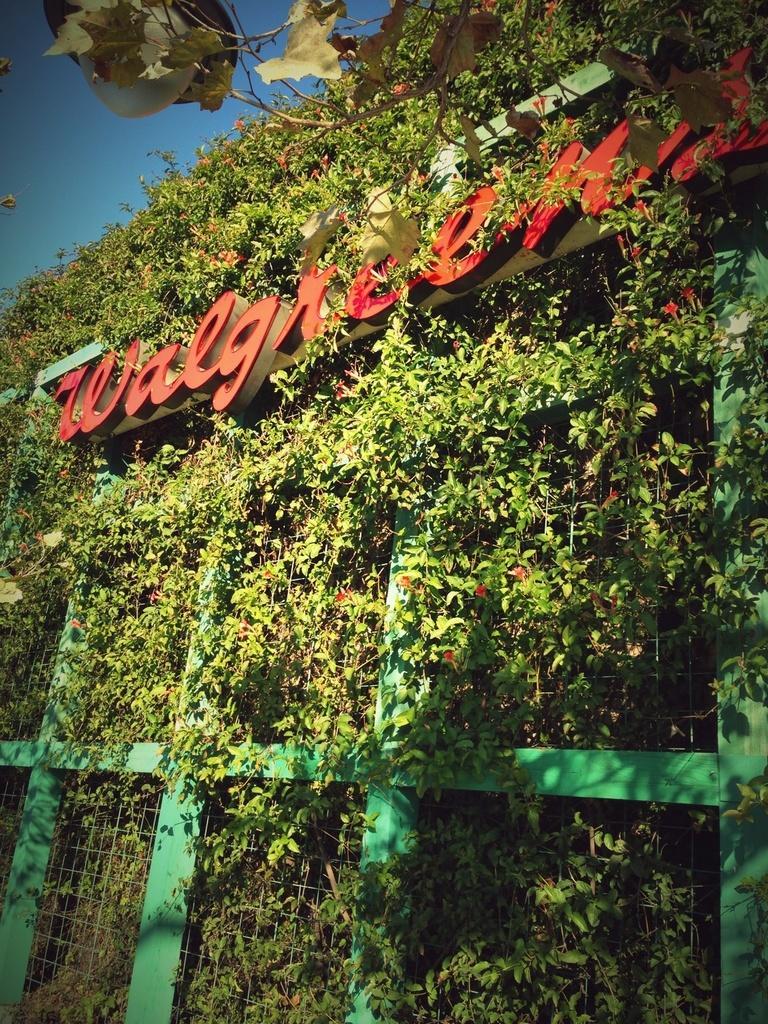Describe this image in one or two sentences. In this image I can see the plants and the red color flowers to it. The plants are attached to the net. I can see something is written on the board. In the back there is a blue sky. 